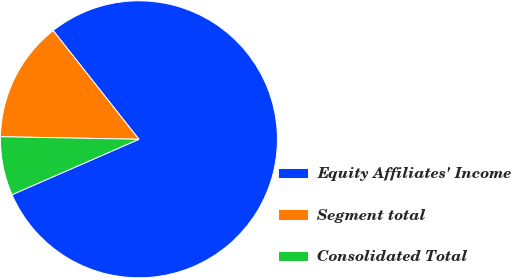<chart> <loc_0><loc_0><loc_500><loc_500><pie_chart><fcel>Equity Affiliates' Income<fcel>Segment total<fcel>Consolidated Total<nl><fcel>79.08%<fcel>14.07%<fcel>6.85%<nl></chart> 